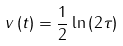<formula> <loc_0><loc_0><loc_500><loc_500>v \left ( t \right ) & = \frac { 1 } { 2 } \ln \left ( 2 \tau \right )</formula> 